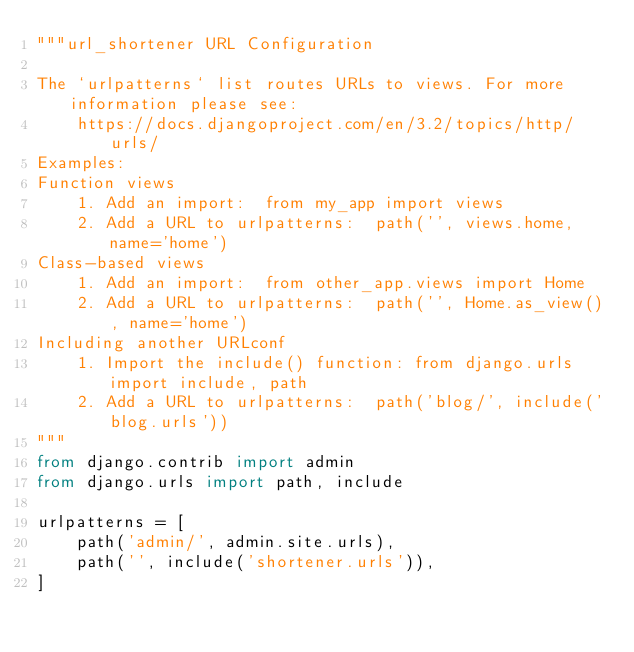<code> <loc_0><loc_0><loc_500><loc_500><_Python_>"""url_shortener URL Configuration

The `urlpatterns` list routes URLs to views. For more information please see:
    https://docs.djangoproject.com/en/3.2/topics/http/urls/
Examples:
Function views
    1. Add an import:  from my_app import views
    2. Add a URL to urlpatterns:  path('', views.home, name='home')
Class-based views
    1. Add an import:  from other_app.views import Home
    2. Add a URL to urlpatterns:  path('', Home.as_view(), name='home')
Including another URLconf
    1. Import the include() function: from django.urls import include, path
    2. Add a URL to urlpatterns:  path('blog/', include('blog.urls'))
"""
from django.contrib import admin
from django.urls import path, include

urlpatterns = [
    path('admin/', admin.site.urls),
    path('', include('shortener.urls')),
]
</code> 